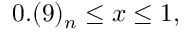<formula> <loc_0><loc_0><loc_500><loc_500>0 . ( 9 ) _ { n } \leq x \leq 1 ,</formula> 